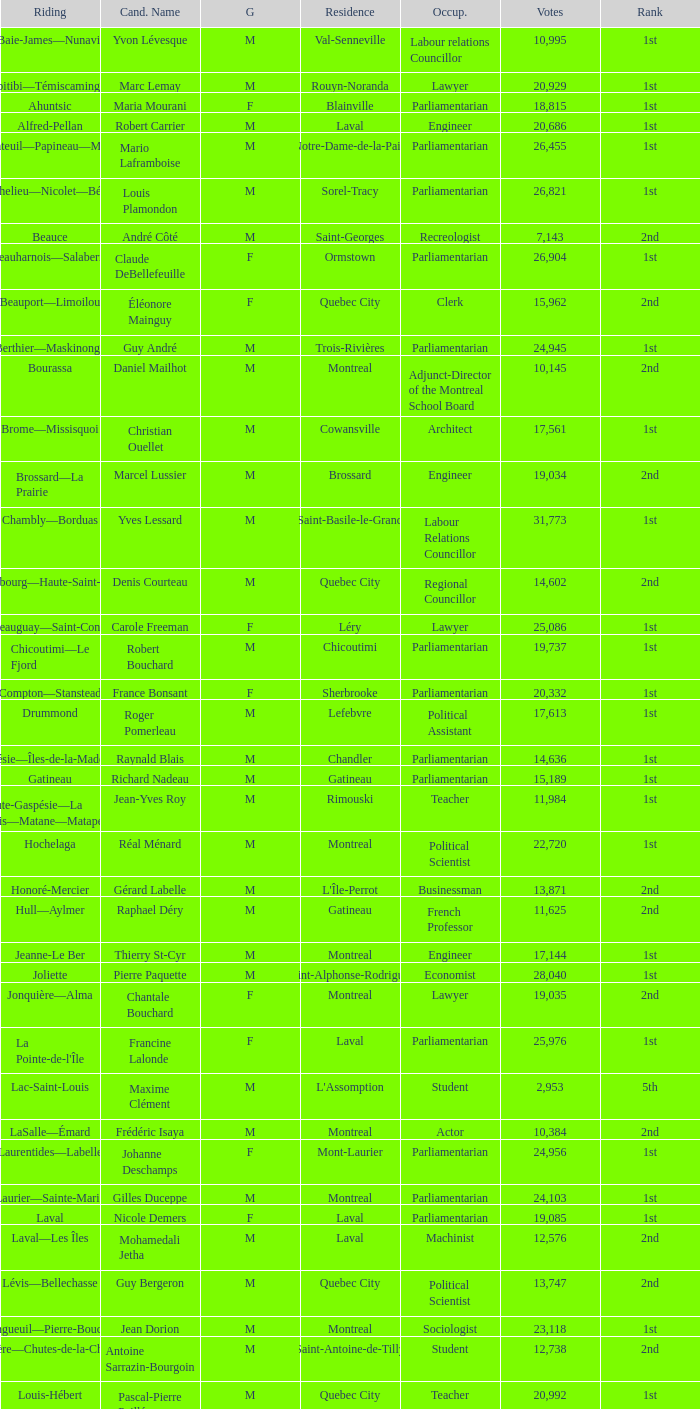What is the highest number of votes for the French Professor? 11625.0. 